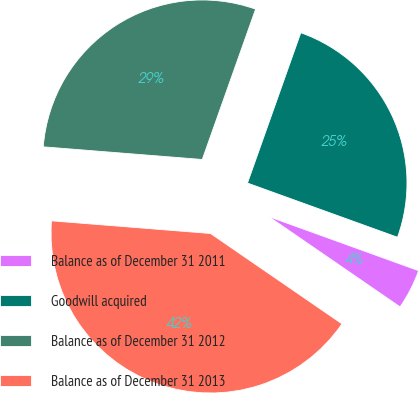<chart> <loc_0><loc_0><loc_500><loc_500><pie_chart><fcel>Balance as of December 31 2011<fcel>Goodwill acquired<fcel>Balance as of December 31 2012<fcel>Balance as of December 31 2013<nl><fcel>4.07%<fcel>25.09%<fcel>29.16%<fcel>41.68%<nl></chart> 